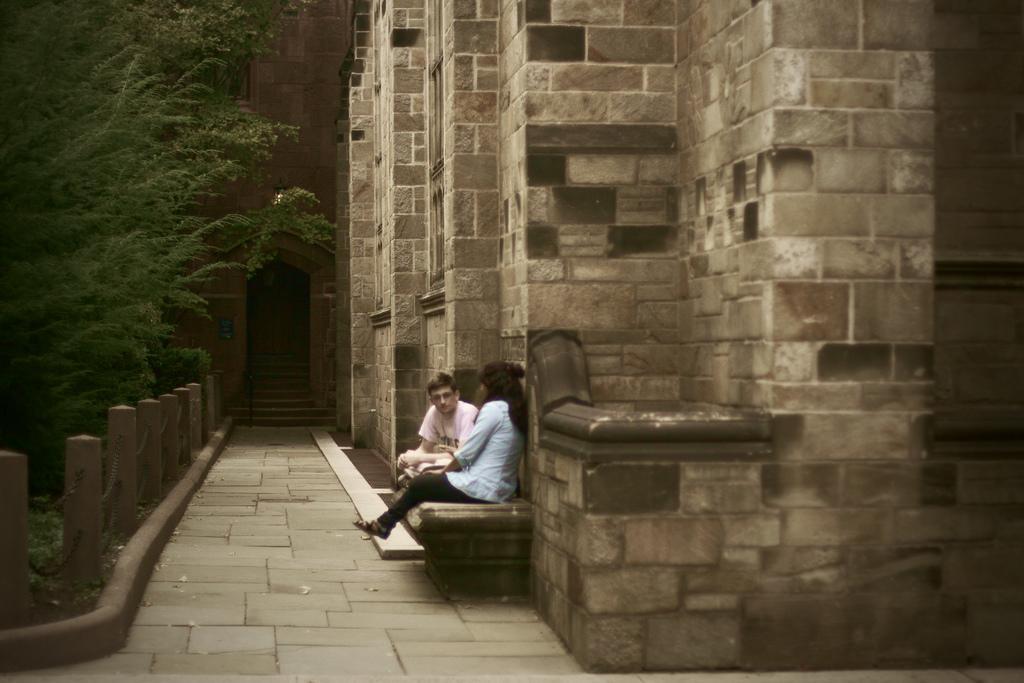How would you summarize this image in a sentence or two? In the image there are two persons sitting on the wall. Behind them there is a wall with pillars. On the left side of the image there are poles with iron chains. Behind them there is a tree. In the background there is a wall with a door. In front of the door there are steps. 